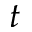Convert formula to latex. <formula><loc_0><loc_0><loc_500><loc_500>t</formula> 